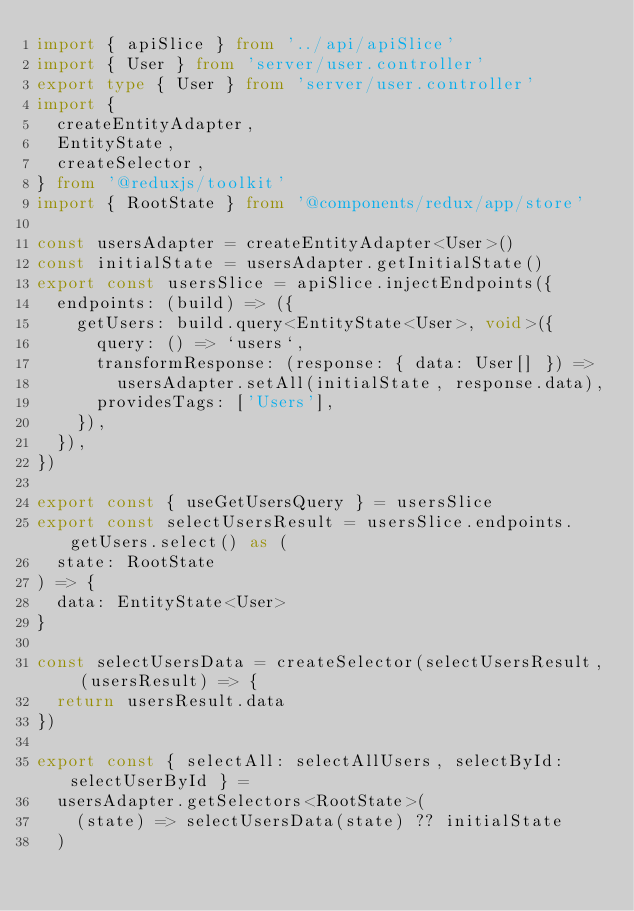<code> <loc_0><loc_0><loc_500><loc_500><_TypeScript_>import { apiSlice } from '../api/apiSlice'
import { User } from 'server/user.controller'
export type { User } from 'server/user.controller'
import {
  createEntityAdapter,
  EntityState,
  createSelector,
} from '@reduxjs/toolkit'
import { RootState } from '@components/redux/app/store'

const usersAdapter = createEntityAdapter<User>()
const initialState = usersAdapter.getInitialState()
export const usersSlice = apiSlice.injectEndpoints({
  endpoints: (build) => ({
    getUsers: build.query<EntityState<User>, void>({
      query: () => `users`,
      transformResponse: (response: { data: User[] }) =>
        usersAdapter.setAll(initialState, response.data),
      providesTags: ['Users'],
    }),
  }),
})

export const { useGetUsersQuery } = usersSlice
export const selectUsersResult = usersSlice.endpoints.getUsers.select() as (
  state: RootState
) => {
  data: EntityState<User>
}

const selectUsersData = createSelector(selectUsersResult, (usersResult) => {
  return usersResult.data
})

export const { selectAll: selectAllUsers, selectById: selectUserById } =
  usersAdapter.getSelectors<RootState>(
    (state) => selectUsersData(state) ?? initialState
  )
</code> 